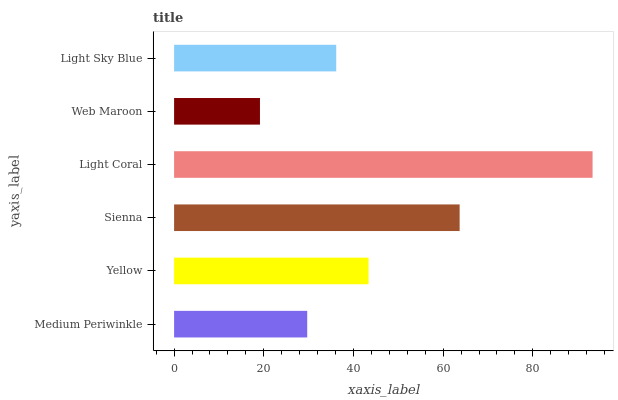Is Web Maroon the minimum?
Answer yes or no. Yes. Is Light Coral the maximum?
Answer yes or no. Yes. Is Yellow the minimum?
Answer yes or no. No. Is Yellow the maximum?
Answer yes or no. No. Is Yellow greater than Medium Periwinkle?
Answer yes or no. Yes. Is Medium Periwinkle less than Yellow?
Answer yes or no. Yes. Is Medium Periwinkle greater than Yellow?
Answer yes or no. No. Is Yellow less than Medium Periwinkle?
Answer yes or no. No. Is Yellow the high median?
Answer yes or no. Yes. Is Light Sky Blue the low median?
Answer yes or no. Yes. Is Light Sky Blue the high median?
Answer yes or no. No. Is Light Coral the low median?
Answer yes or no. No. 